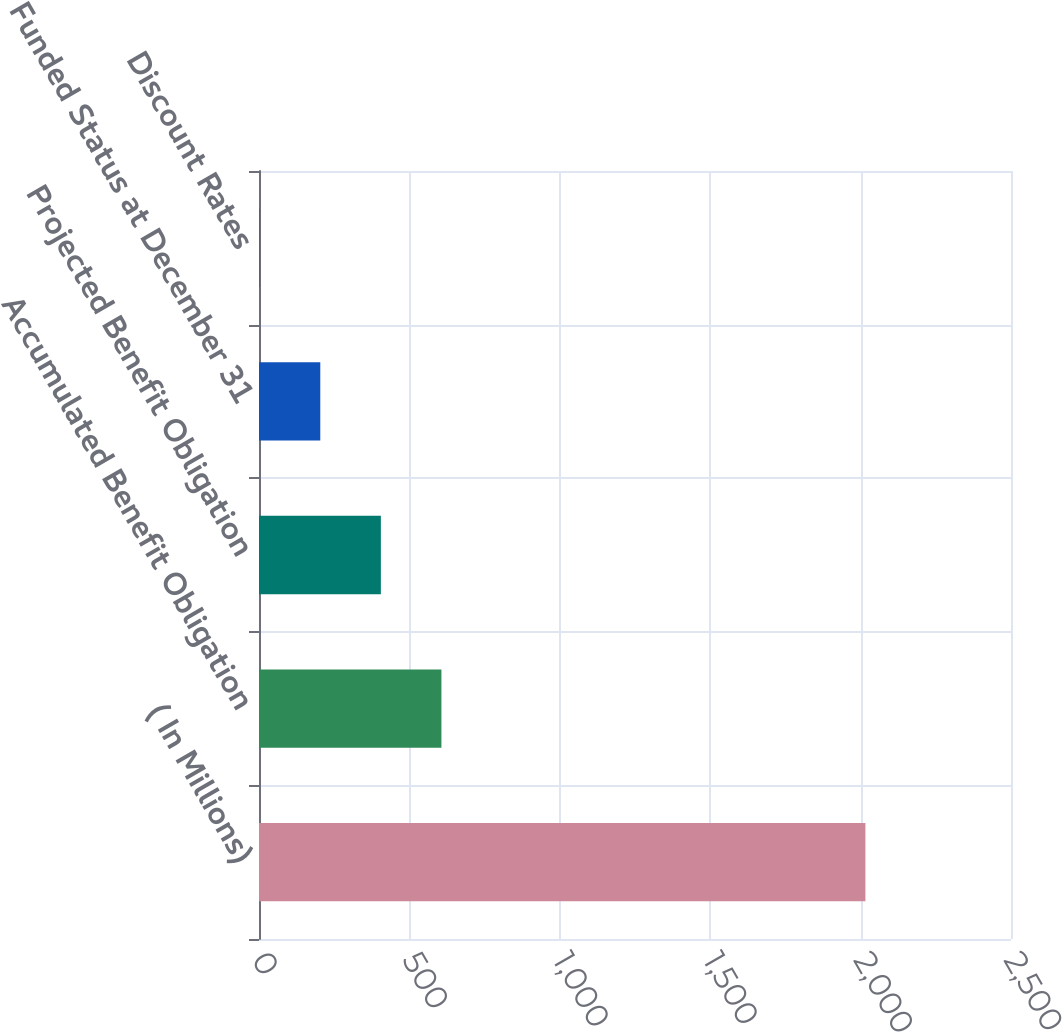Convert chart. <chart><loc_0><loc_0><loc_500><loc_500><bar_chart><fcel>( In Millions)<fcel>Accumulated Benefit Obligation<fcel>Projected Benefit Obligation<fcel>Funded Status at December 31<fcel>Discount Rates<nl><fcel>2016<fcel>606.47<fcel>405.11<fcel>203.75<fcel>2.39<nl></chart> 